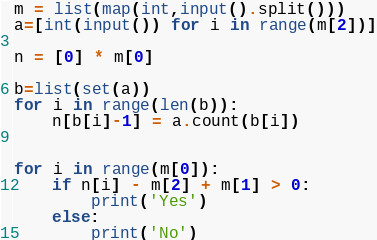Convert code to text. <code><loc_0><loc_0><loc_500><loc_500><_Python_>m = list(map(int,input().split()))
a=[int(input()) for i in range(m[2])]

n = [0] * m[0]

b=list(set(a))
for i in range(len(b)):
    n[b[i]-1] = a.count(b[i])

  
for i in range(m[0]):
    if n[i] - m[2] + m[1] > 0:
        print('Yes')
    else:
        print('No')</code> 